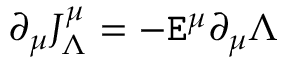Convert formula to latex. <formula><loc_0><loc_0><loc_500><loc_500>\partial _ { \mu } J _ { \Lambda } ^ { \mu } = - E ^ { \mu } \partial _ { \mu } \Lambda</formula> 